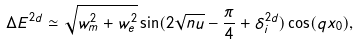Convert formula to latex. <formula><loc_0><loc_0><loc_500><loc_500>\Delta E ^ { 2 d } \simeq \sqrt { w _ { m } ^ { 2 } + w _ { e } ^ { 2 } } \sin ( 2 \sqrt { n u } - \frac { \pi } { 4 } + \delta _ { i } ^ { 2 d } ) \cos ( q x _ { 0 } ) ,</formula> 